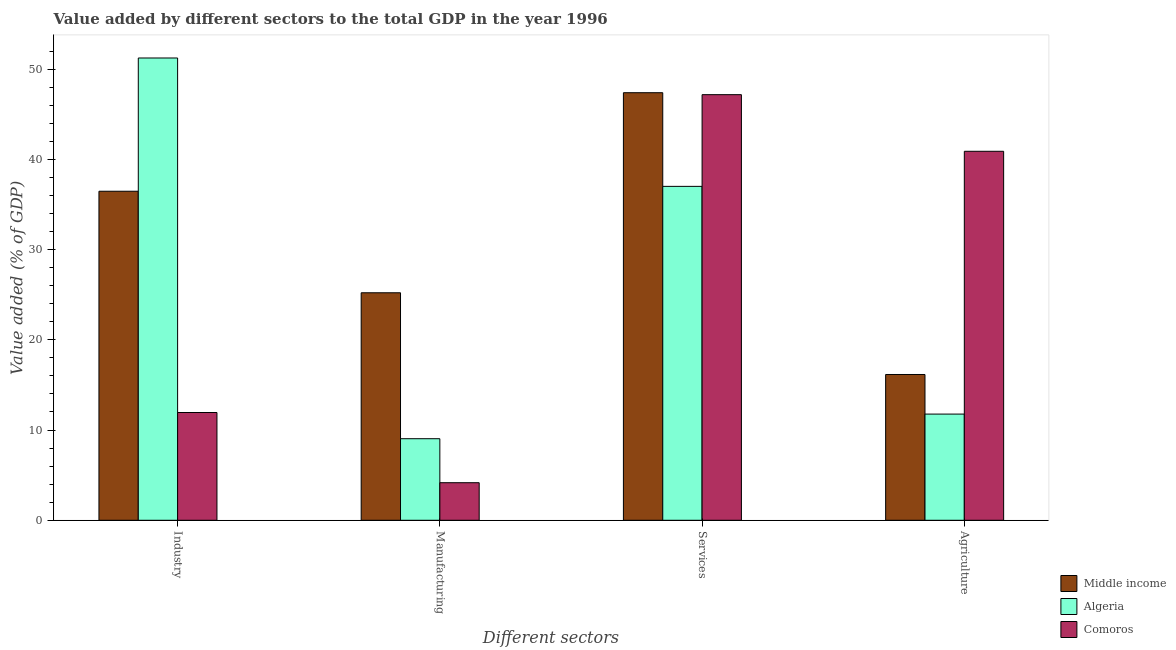How many groups of bars are there?
Give a very brief answer. 4. Are the number of bars on each tick of the X-axis equal?
Ensure brevity in your answer.  Yes. What is the label of the 4th group of bars from the left?
Offer a very short reply. Agriculture. What is the value added by services sector in Algeria?
Ensure brevity in your answer.  37. Across all countries, what is the maximum value added by industrial sector?
Your answer should be compact. 51.23. Across all countries, what is the minimum value added by services sector?
Provide a succinct answer. 37. In which country was the value added by agricultural sector maximum?
Provide a succinct answer. Comoros. In which country was the value added by manufacturing sector minimum?
Your answer should be compact. Comoros. What is the total value added by manufacturing sector in the graph?
Give a very brief answer. 38.41. What is the difference between the value added by industrial sector in Algeria and that in Middle income?
Keep it short and to the point. 14.77. What is the difference between the value added by manufacturing sector in Algeria and the value added by services sector in Middle income?
Your answer should be very brief. -38.34. What is the average value added by manufacturing sector per country?
Keep it short and to the point. 12.8. What is the difference between the value added by services sector and value added by manufacturing sector in Algeria?
Ensure brevity in your answer.  27.96. What is the ratio of the value added by services sector in Middle income to that in Comoros?
Your response must be concise. 1. Is the difference between the value added by services sector in Algeria and Comoros greater than the difference between the value added by manufacturing sector in Algeria and Comoros?
Provide a succinct answer. No. What is the difference between the highest and the second highest value added by services sector?
Keep it short and to the point. 0.22. What is the difference between the highest and the lowest value added by agricultural sector?
Make the answer very short. 29.12. Is the sum of the value added by manufacturing sector in Middle income and Comoros greater than the maximum value added by industrial sector across all countries?
Ensure brevity in your answer.  No. What does the 3rd bar from the left in Manufacturing represents?
Keep it short and to the point. Comoros. What does the 1st bar from the right in Agriculture represents?
Offer a terse response. Comoros. Is it the case that in every country, the sum of the value added by industrial sector and value added by manufacturing sector is greater than the value added by services sector?
Provide a succinct answer. No. Are all the bars in the graph horizontal?
Your answer should be compact. No. How many countries are there in the graph?
Ensure brevity in your answer.  3. Does the graph contain any zero values?
Keep it short and to the point. No. Does the graph contain grids?
Your response must be concise. No. How are the legend labels stacked?
Ensure brevity in your answer.  Vertical. What is the title of the graph?
Keep it short and to the point. Value added by different sectors to the total GDP in the year 1996. What is the label or title of the X-axis?
Keep it short and to the point. Different sectors. What is the label or title of the Y-axis?
Your answer should be very brief. Value added (% of GDP). What is the Value added (% of GDP) in Middle income in Industry?
Your response must be concise. 36.46. What is the Value added (% of GDP) of Algeria in Industry?
Keep it short and to the point. 51.23. What is the Value added (% of GDP) in Comoros in Industry?
Your answer should be compact. 11.94. What is the Value added (% of GDP) of Middle income in Manufacturing?
Give a very brief answer. 25.21. What is the Value added (% of GDP) of Algeria in Manufacturing?
Provide a short and direct response. 9.04. What is the Value added (% of GDP) of Comoros in Manufacturing?
Your answer should be very brief. 4.16. What is the Value added (% of GDP) in Middle income in Services?
Offer a very short reply. 47.38. What is the Value added (% of GDP) of Algeria in Services?
Provide a succinct answer. 37. What is the Value added (% of GDP) of Comoros in Services?
Provide a succinct answer. 47.17. What is the Value added (% of GDP) in Middle income in Agriculture?
Offer a very short reply. 16.15. What is the Value added (% of GDP) of Algeria in Agriculture?
Provide a short and direct response. 11.77. What is the Value added (% of GDP) in Comoros in Agriculture?
Provide a succinct answer. 40.89. Across all Different sectors, what is the maximum Value added (% of GDP) in Middle income?
Provide a succinct answer. 47.38. Across all Different sectors, what is the maximum Value added (% of GDP) of Algeria?
Make the answer very short. 51.23. Across all Different sectors, what is the maximum Value added (% of GDP) of Comoros?
Give a very brief answer. 47.17. Across all Different sectors, what is the minimum Value added (% of GDP) in Middle income?
Keep it short and to the point. 16.15. Across all Different sectors, what is the minimum Value added (% of GDP) of Algeria?
Provide a succinct answer. 9.04. Across all Different sectors, what is the minimum Value added (% of GDP) in Comoros?
Your answer should be very brief. 4.16. What is the total Value added (% of GDP) of Middle income in the graph?
Give a very brief answer. 125.21. What is the total Value added (% of GDP) of Algeria in the graph?
Make the answer very short. 109.04. What is the total Value added (% of GDP) of Comoros in the graph?
Your answer should be compact. 104.16. What is the difference between the Value added (% of GDP) in Middle income in Industry and that in Manufacturing?
Your answer should be compact. 11.25. What is the difference between the Value added (% of GDP) of Algeria in Industry and that in Manufacturing?
Offer a very short reply. 42.19. What is the difference between the Value added (% of GDP) of Comoros in Industry and that in Manufacturing?
Make the answer very short. 7.78. What is the difference between the Value added (% of GDP) in Middle income in Industry and that in Services?
Offer a terse response. -10.92. What is the difference between the Value added (% of GDP) in Algeria in Industry and that in Services?
Your answer should be compact. 14.23. What is the difference between the Value added (% of GDP) of Comoros in Industry and that in Services?
Provide a short and direct response. -35.22. What is the difference between the Value added (% of GDP) in Middle income in Industry and that in Agriculture?
Your response must be concise. 20.31. What is the difference between the Value added (% of GDP) in Algeria in Industry and that in Agriculture?
Give a very brief answer. 39.46. What is the difference between the Value added (% of GDP) of Comoros in Industry and that in Agriculture?
Provide a succinct answer. -28.95. What is the difference between the Value added (% of GDP) in Middle income in Manufacturing and that in Services?
Offer a terse response. -22.17. What is the difference between the Value added (% of GDP) in Algeria in Manufacturing and that in Services?
Your answer should be very brief. -27.96. What is the difference between the Value added (% of GDP) in Comoros in Manufacturing and that in Services?
Your answer should be very brief. -43. What is the difference between the Value added (% of GDP) of Middle income in Manufacturing and that in Agriculture?
Offer a very short reply. 9.06. What is the difference between the Value added (% of GDP) in Algeria in Manufacturing and that in Agriculture?
Make the answer very short. -2.73. What is the difference between the Value added (% of GDP) of Comoros in Manufacturing and that in Agriculture?
Ensure brevity in your answer.  -36.73. What is the difference between the Value added (% of GDP) of Middle income in Services and that in Agriculture?
Your response must be concise. 31.23. What is the difference between the Value added (% of GDP) in Algeria in Services and that in Agriculture?
Ensure brevity in your answer.  25.24. What is the difference between the Value added (% of GDP) of Comoros in Services and that in Agriculture?
Offer a terse response. 6.27. What is the difference between the Value added (% of GDP) of Middle income in Industry and the Value added (% of GDP) of Algeria in Manufacturing?
Ensure brevity in your answer.  27.42. What is the difference between the Value added (% of GDP) of Middle income in Industry and the Value added (% of GDP) of Comoros in Manufacturing?
Provide a succinct answer. 32.3. What is the difference between the Value added (% of GDP) in Algeria in Industry and the Value added (% of GDP) in Comoros in Manufacturing?
Your answer should be compact. 47.07. What is the difference between the Value added (% of GDP) of Middle income in Industry and the Value added (% of GDP) of Algeria in Services?
Make the answer very short. -0.54. What is the difference between the Value added (% of GDP) of Middle income in Industry and the Value added (% of GDP) of Comoros in Services?
Your answer should be compact. -10.7. What is the difference between the Value added (% of GDP) of Algeria in Industry and the Value added (% of GDP) of Comoros in Services?
Your response must be concise. 4.06. What is the difference between the Value added (% of GDP) of Middle income in Industry and the Value added (% of GDP) of Algeria in Agriculture?
Offer a very short reply. 24.7. What is the difference between the Value added (% of GDP) in Middle income in Industry and the Value added (% of GDP) in Comoros in Agriculture?
Your response must be concise. -4.43. What is the difference between the Value added (% of GDP) in Algeria in Industry and the Value added (% of GDP) in Comoros in Agriculture?
Provide a succinct answer. 10.34. What is the difference between the Value added (% of GDP) of Middle income in Manufacturing and the Value added (% of GDP) of Algeria in Services?
Offer a very short reply. -11.79. What is the difference between the Value added (% of GDP) in Middle income in Manufacturing and the Value added (% of GDP) in Comoros in Services?
Ensure brevity in your answer.  -21.96. What is the difference between the Value added (% of GDP) in Algeria in Manufacturing and the Value added (% of GDP) in Comoros in Services?
Provide a short and direct response. -38.13. What is the difference between the Value added (% of GDP) in Middle income in Manufacturing and the Value added (% of GDP) in Algeria in Agriculture?
Your answer should be compact. 13.44. What is the difference between the Value added (% of GDP) of Middle income in Manufacturing and the Value added (% of GDP) of Comoros in Agriculture?
Give a very brief answer. -15.68. What is the difference between the Value added (% of GDP) of Algeria in Manufacturing and the Value added (% of GDP) of Comoros in Agriculture?
Offer a terse response. -31.85. What is the difference between the Value added (% of GDP) of Middle income in Services and the Value added (% of GDP) of Algeria in Agriculture?
Make the answer very short. 35.62. What is the difference between the Value added (% of GDP) of Middle income in Services and the Value added (% of GDP) of Comoros in Agriculture?
Give a very brief answer. 6.49. What is the difference between the Value added (% of GDP) in Algeria in Services and the Value added (% of GDP) in Comoros in Agriculture?
Your answer should be very brief. -3.89. What is the average Value added (% of GDP) in Middle income per Different sectors?
Your answer should be very brief. 31.3. What is the average Value added (% of GDP) in Algeria per Different sectors?
Provide a succinct answer. 27.26. What is the average Value added (% of GDP) in Comoros per Different sectors?
Keep it short and to the point. 26.04. What is the difference between the Value added (% of GDP) in Middle income and Value added (% of GDP) in Algeria in Industry?
Your response must be concise. -14.77. What is the difference between the Value added (% of GDP) of Middle income and Value added (% of GDP) of Comoros in Industry?
Keep it short and to the point. 24.52. What is the difference between the Value added (% of GDP) in Algeria and Value added (% of GDP) in Comoros in Industry?
Make the answer very short. 39.29. What is the difference between the Value added (% of GDP) of Middle income and Value added (% of GDP) of Algeria in Manufacturing?
Your answer should be very brief. 16.17. What is the difference between the Value added (% of GDP) in Middle income and Value added (% of GDP) in Comoros in Manufacturing?
Keep it short and to the point. 21.05. What is the difference between the Value added (% of GDP) of Algeria and Value added (% of GDP) of Comoros in Manufacturing?
Keep it short and to the point. 4.88. What is the difference between the Value added (% of GDP) in Middle income and Value added (% of GDP) in Algeria in Services?
Provide a short and direct response. 10.38. What is the difference between the Value added (% of GDP) in Middle income and Value added (% of GDP) in Comoros in Services?
Make the answer very short. 0.22. What is the difference between the Value added (% of GDP) of Algeria and Value added (% of GDP) of Comoros in Services?
Your answer should be very brief. -10.16. What is the difference between the Value added (% of GDP) in Middle income and Value added (% of GDP) in Algeria in Agriculture?
Provide a short and direct response. 4.39. What is the difference between the Value added (% of GDP) of Middle income and Value added (% of GDP) of Comoros in Agriculture?
Make the answer very short. -24.74. What is the difference between the Value added (% of GDP) in Algeria and Value added (% of GDP) in Comoros in Agriculture?
Your answer should be very brief. -29.12. What is the ratio of the Value added (% of GDP) in Middle income in Industry to that in Manufacturing?
Ensure brevity in your answer.  1.45. What is the ratio of the Value added (% of GDP) in Algeria in Industry to that in Manufacturing?
Provide a succinct answer. 5.67. What is the ratio of the Value added (% of GDP) in Comoros in Industry to that in Manufacturing?
Offer a terse response. 2.87. What is the ratio of the Value added (% of GDP) in Middle income in Industry to that in Services?
Offer a terse response. 0.77. What is the ratio of the Value added (% of GDP) of Algeria in Industry to that in Services?
Your answer should be compact. 1.38. What is the ratio of the Value added (% of GDP) of Comoros in Industry to that in Services?
Provide a short and direct response. 0.25. What is the ratio of the Value added (% of GDP) in Middle income in Industry to that in Agriculture?
Ensure brevity in your answer.  2.26. What is the ratio of the Value added (% of GDP) of Algeria in Industry to that in Agriculture?
Your answer should be compact. 4.35. What is the ratio of the Value added (% of GDP) in Comoros in Industry to that in Agriculture?
Offer a terse response. 0.29. What is the ratio of the Value added (% of GDP) in Middle income in Manufacturing to that in Services?
Provide a short and direct response. 0.53. What is the ratio of the Value added (% of GDP) of Algeria in Manufacturing to that in Services?
Keep it short and to the point. 0.24. What is the ratio of the Value added (% of GDP) in Comoros in Manufacturing to that in Services?
Your answer should be very brief. 0.09. What is the ratio of the Value added (% of GDP) of Middle income in Manufacturing to that in Agriculture?
Provide a short and direct response. 1.56. What is the ratio of the Value added (% of GDP) of Algeria in Manufacturing to that in Agriculture?
Provide a succinct answer. 0.77. What is the ratio of the Value added (% of GDP) in Comoros in Manufacturing to that in Agriculture?
Offer a very short reply. 0.1. What is the ratio of the Value added (% of GDP) of Middle income in Services to that in Agriculture?
Give a very brief answer. 2.93. What is the ratio of the Value added (% of GDP) of Algeria in Services to that in Agriculture?
Make the answer very short. 3.14. What is the ratio of the Value added (% of GDP) in Comoros in Services to that in Agriculture?
Give a very brief answer. 1.15. What is the difference between the highest and the second highest Value added (% of GDP) in Middle income?
Offer a very short reply. 10.92. What is the difference between the highest and the second highest Value added (% of GDP) in Algeria?
Provide a succinct answer. 14.23. What is the difference between the highest and the second highest Value added (% of GDP) of Comoros?
Your answer should be compact. 6.27. What is the difference between the highest and the lowest Value added (% of GDP) in Middle income?
Offer a terse response. 31.23. What is the difference between the highest and the lowest Value added (% of GDP) in Algeria?
Keep it short and to the point. 42.19. What is the difference between the highest and the lowest Value added (% of GDP) in Comoros?
Make the answer very short. 43. 